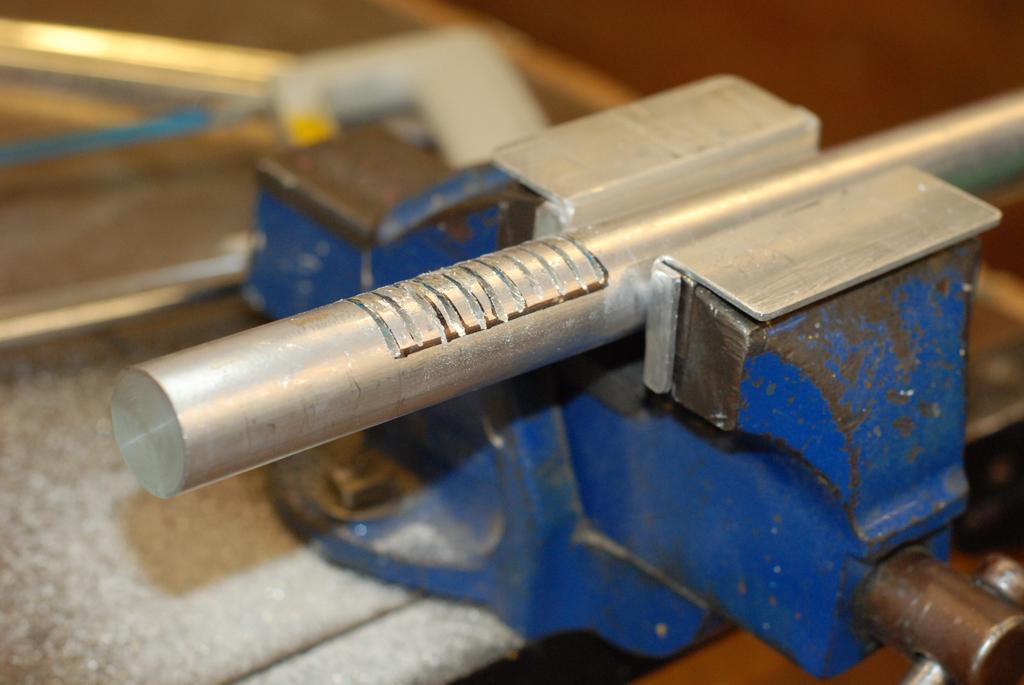In one or two sentences, can you explain what this image depicts? In this image there is a tool at right side of this image and there is a iron rod in middle of this image. 